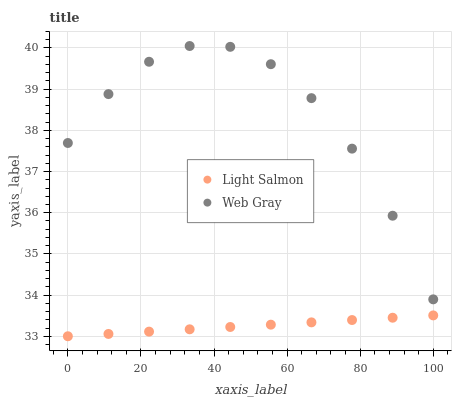Does Light Salmon have the minimum area under the curve?
Answer yes or no. Yes. Does Web Gray have the maximum area under the curve?
Answer yes or no. Yes. Does Web Gray have the minimum area under the curve?
Answer yes or no. No. Is Light Salmon the smoothest?
Answer yes or no. Yes. Is Web Gray the roughest?
Answer yes or no. Yes. Is Web Gray the smoothest?
Answer yes or no. No. Does Light Salmon have the lowest value?
Answer yes or no. Yes. Does Web Gray have the lowest value?
Answer yes or no. No. Does Web Gray have the highest value?
Answer yes or no. Yes. Is Light Salmon less than Web Gray?
Answer yes or no. Yes. Is Web Gray greater than Light Salmon?
Answer yes or no. Yes. Does Light Salmon intersect Web Gray?
Answer yes or no. No. 